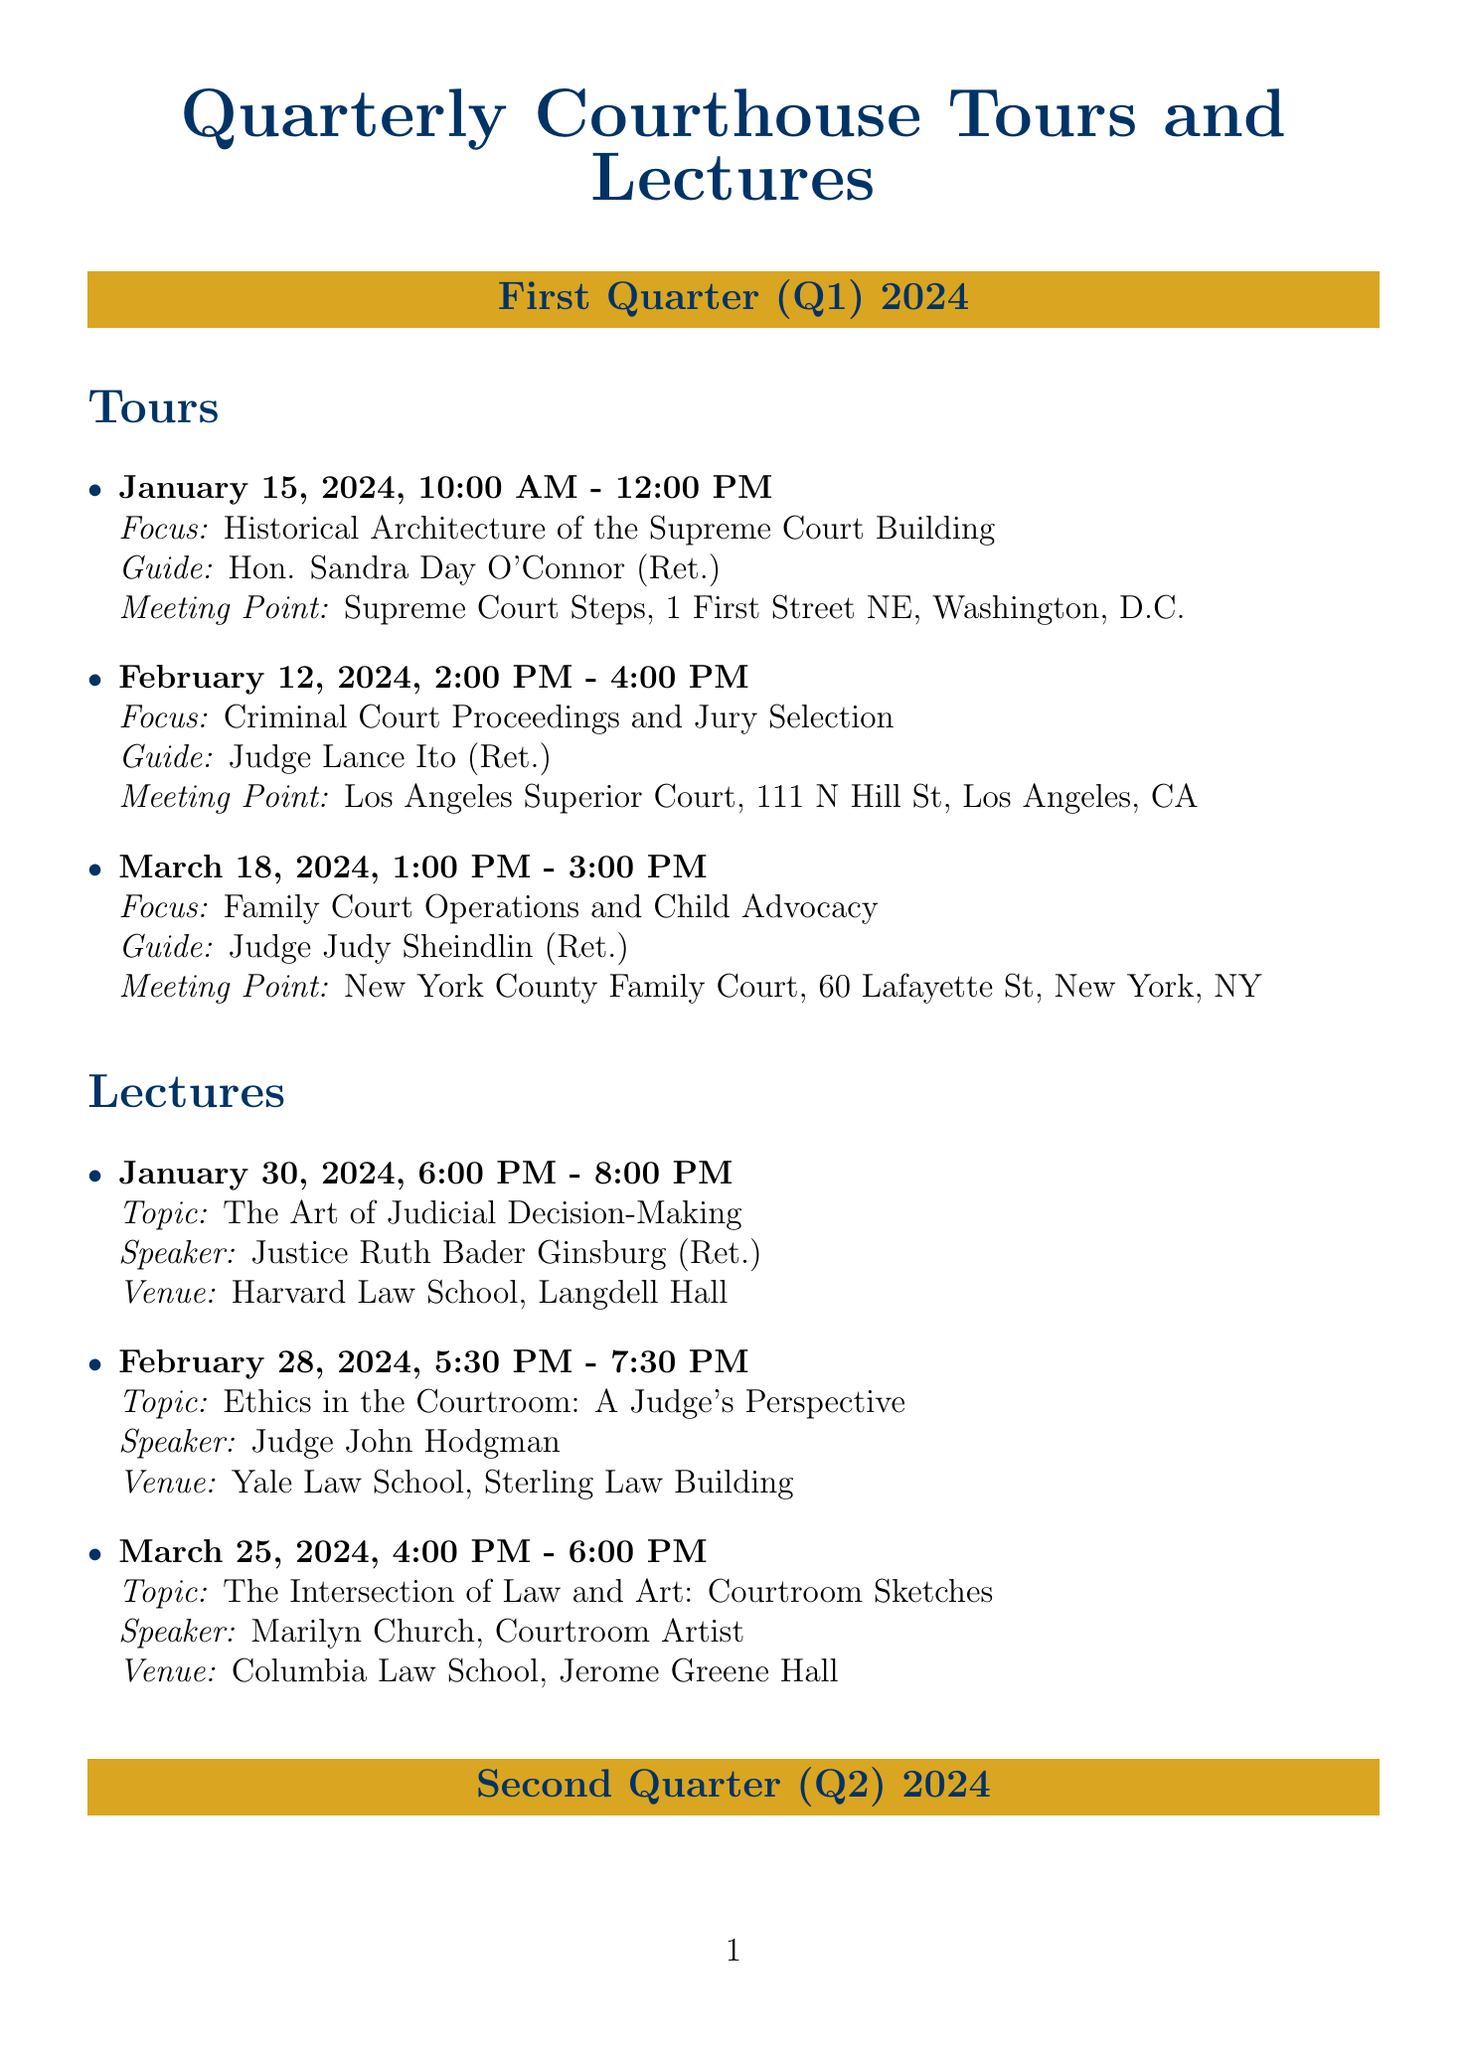what is the date of the first tour? The date of the first tour is specified in the document as January 15, 2024.
Answer: January 15, 2024 who is the guide for the tour on February 12, 2024? The guide for the February 12, 2024 tour is stated in the document as Judge Lance Ito (Ret.).
Answer: Judge Lance Ito (Ret.) what is the topic of the lecture on April 22, 2024? The topic of the lecture on April 22, 2024 is provided in the document as The Role of Judges in Shaping Constitutional Law.
Answer: The Role of Judges in Shaping Constitutional Law how many lectures are scheduled in Q2 2024? The number of lectures scheduled in Q2 2024 is determined by counting the entries under that section, which total three.
Answer: 3 where is the meeting point for the tour on June 10, 2024? The meeting point for the June 10, 2024 tour is indicated in the document as United States Bankruptcy Court, Southern District of New York, One Bowling Green, New York, NY.
Answer: United States Bankruptcy Court, Southern District of New York, One Bowling Green, New York, NY who is the speaker for the May 15, 2024 lecture? The speaker for the May 15, 2024 lecture is mentioned in the document as Nelson Shanks, Portrait Artist.
Answer: Nelson Shanks, Portrait Artist what focus area is covered in the tour on March 18, 2024? The focus area for the tour on March 18, 2024 is detailed in the document as Family Court Operations and Child Advocacy.
Answer: Family Court Operations and Child Advocacy which quarter has the most tours scheduled? The quarters are compared based on their tour listings in the document, both Q1 and Q2 have three tours, so neither quarter has more scheduled.
Answer: Neither quarter 